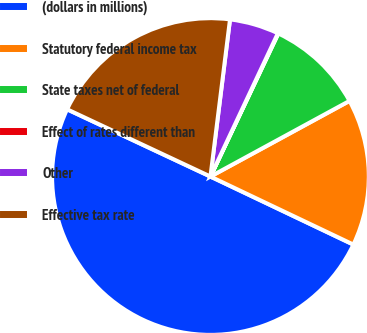Convert chart to OTSL. <chart><loc_0><loc_0><loc_500><loc_500><pie_chart><fcel>(dollars in millions)<fcel>Statutory federal income tax<fcel>State taxes net of federal<fcel>Effect of rates different than<fcel>Other<fcel>Effective tax rate<nl><fcel>49.91%<fcel>15.0%<fcel>10.02%<fcel>0.05%<fcel>5.03%<fcel>19.99%<nl></chart> 